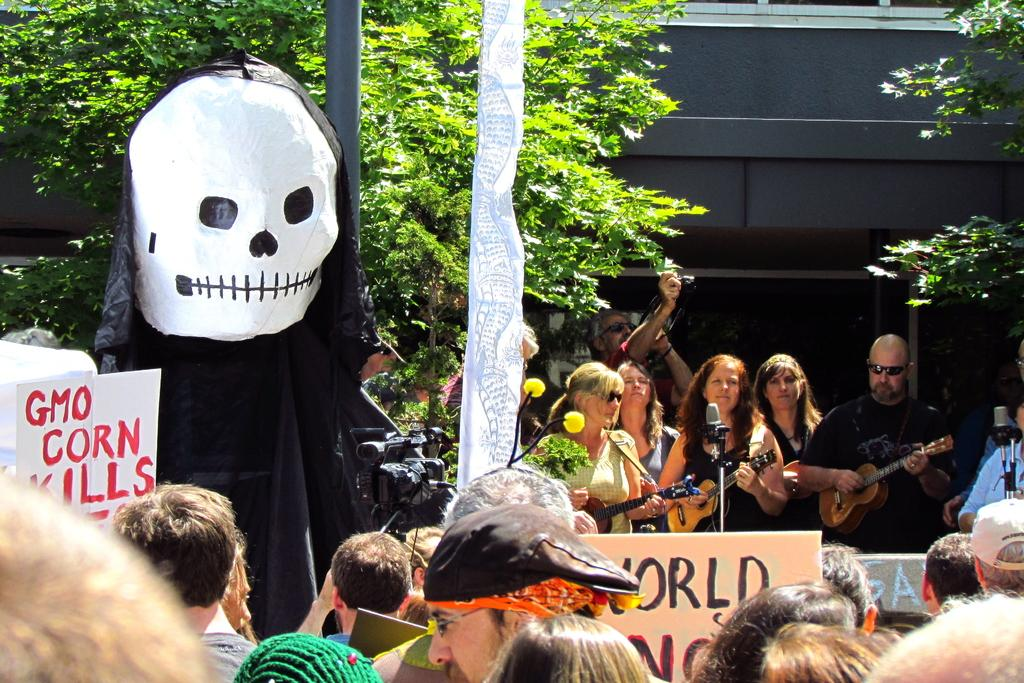How many persons are in the image? There are persons in the image. What are some of the persons holding in the image? Three of the persons are holding guitars. What type of vegetation is visible in the image? There are trees in the image. Can you describe the people in the image? There are people in the image. What objects can be seen in the image besides the persons and guitars? There are two boards in the image. How many worms can be seen crawling on the guitars in the image? There are no worms visible in the image, as it features persons holding guitars and other objects. What type of wealth is depicted in the image? There is no depiction of wealth in the image; it focuses on persons, guitars, trees, people, and boards. 